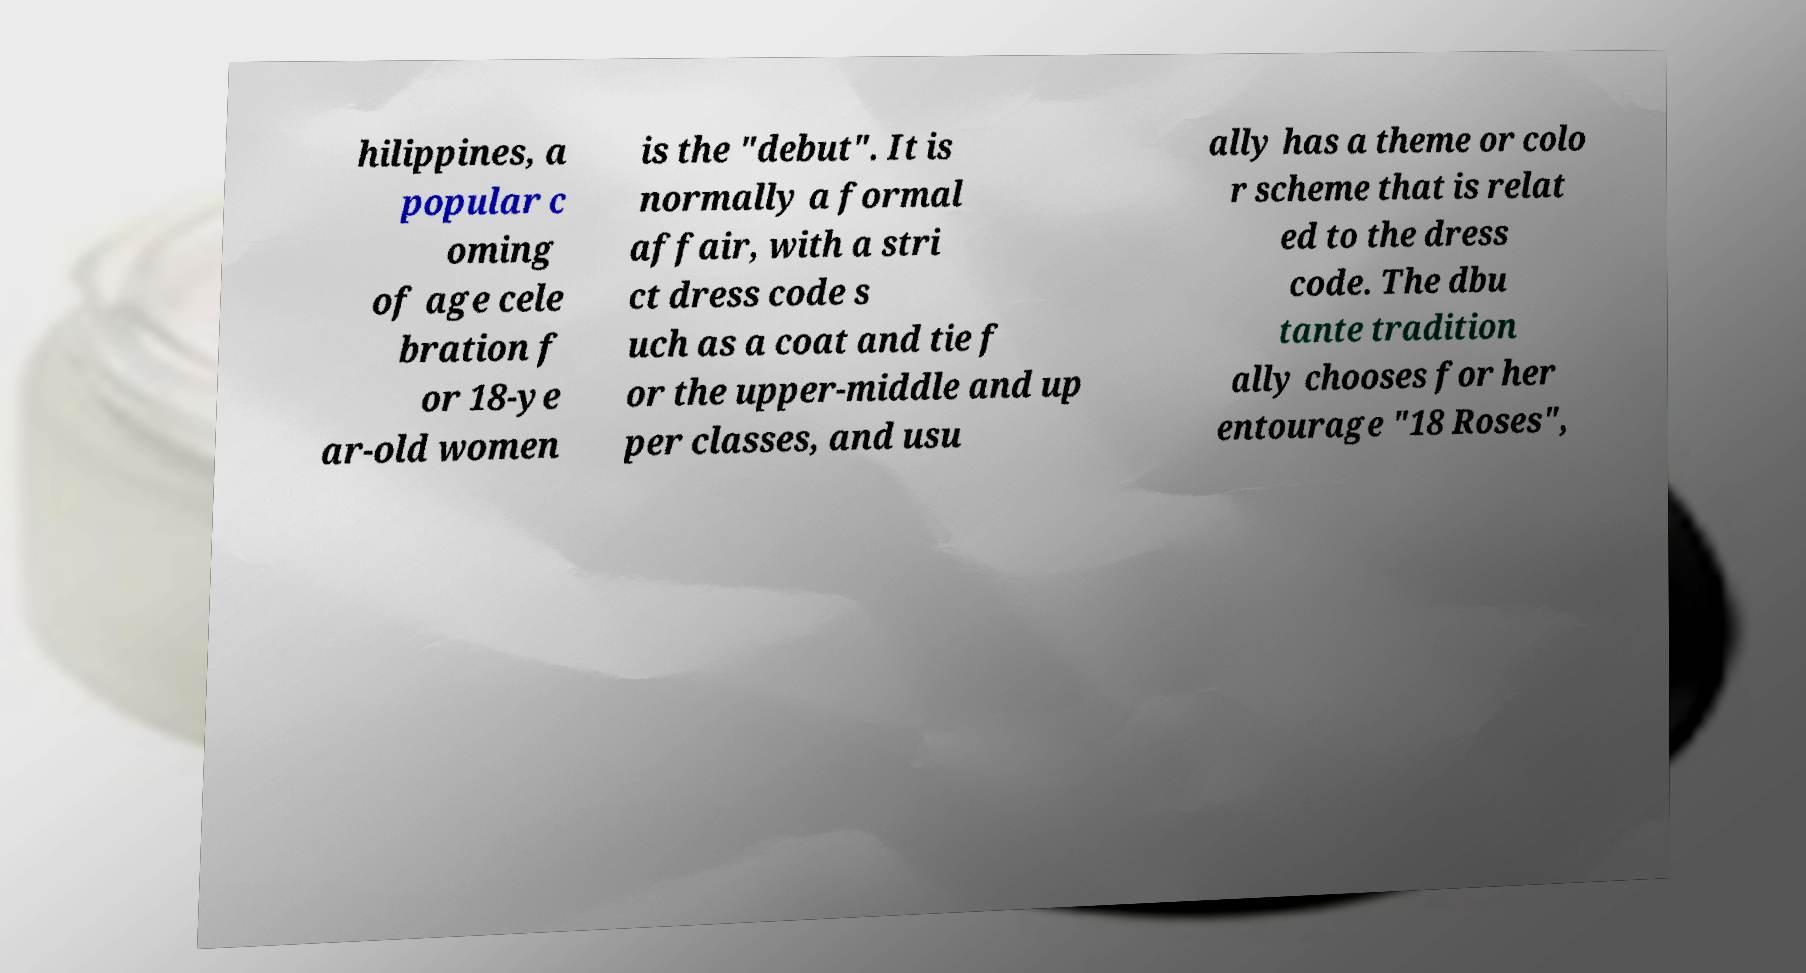I need the written content from this picture converted into text. Can you do that? hilippines, a popular c oming of age cele bration f or 18-ye ar-old women is the "debut". It is normally a formal affair, with a stri ct dress code s uch as a coat and tie f or the upper-middle and up per classes, and usu ally has a theme or colo r scheme that is relat ed to the dress code. The dbu tante tradition ally chooses for her entourage "18 Roses", 